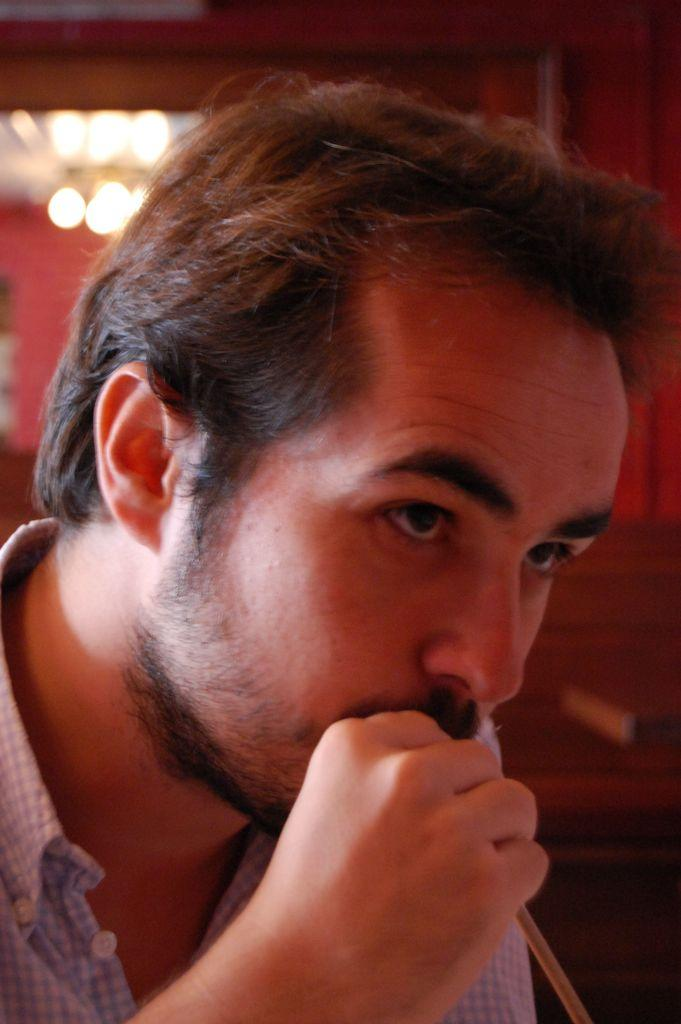Who or what is present in the image? There is a person in the image. What is the person holding in the image? The person is holding a straw. What can be seen in the image besides the person? There are lights visible in the image. What type of structure is present in the image? There is a wall in the image. How would you describe the background of the image? The background of the image is blurred. Where is the cobweb located in the image? There is no cobweb present in the image. What type of club can be seen in the image? There is no club present in the image. 